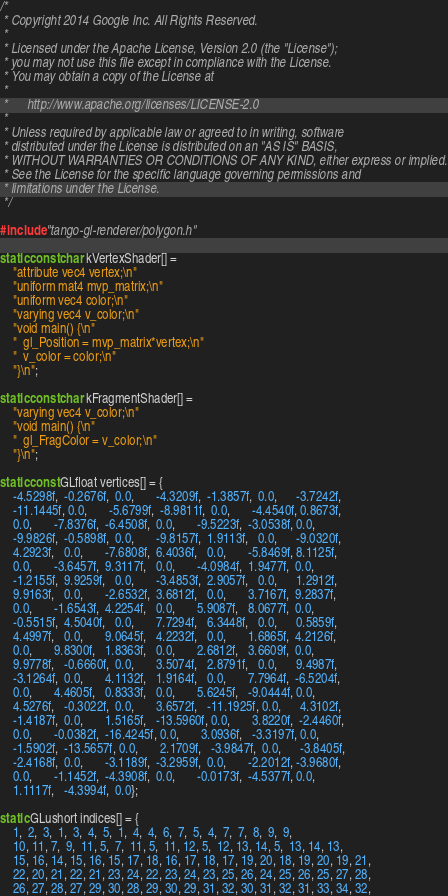Convert code to text. <code><loc_0><loc_0><loc_500><loc_500><_C++_>/*
 * Copyright 2014 Google Inc. All Rights Reserved.
 *
 * Licensed under the Apache License, Version 2.0 (the "License");
 * you may not use this file except in compliance with the License.
 * You may obtain a copy of the License at
 *
 *      http://www.apache.org/licenses/LICENSE-2.0
 *
 * Unless required by applicable law or agreed to in writing, software
 * distributed under the License is distributed on an "AS IS" BASIS,
 * WITHOUT WARRANTIES OR CONDITIONS OF ANY KIND, either express or implied.
 * See the License for the specific language governing permissions and
 * limitations under the License.
 */

#include "tango-gl-renderer/polygon.h"

static const char kVertexShader[] =
    "attribute vec4 vertex;\n"
    "uniform mat4 mvp_matrix;\n"
    "uniform vec4 color;\n"
    "varying vec4 v_color;\n"
    "void main() {\n"
    "  gl_Position = mvp_matrix*vertex;\n"
    "  v_color = color;\n"
    "}\n";

static const char kFragmentShader[] =
    "varying vec4 v_color;\n"
    "void main() {\n"
    "  gl_FragColor = v_color;\n"
    "}\n";

static const GLfloat vertices[] = {
    -4.5298f,  -0.2676f,  0.0,       -4.3209f,  -1.3857f,  0.0,      -3.7242f,
    -11.1445f, 0.0,       -5.6799f,  -8.9811f,  0.0,       -4.4540f, 0.8673f,
    0.0,       -7.8376f,  -6.4508f,  0.0,       -9.5223f,  -3.0538f, 0.0,
    -9.9826f,  -0.5898f,  0.0,       -9.8157f,  1.9113f,   0.0,      -9.0320f,
    4.2923f,   0.0,       -7.6808f,  6.4036f,   0.0,       -5.8469f, 8.1125f,
    0.0,       -3.6457f,  9.3117f,   0.0,       -4.0984f,  1.9477f,  0.0,
    -1.2155f,  9.9259f,   0.0,       -3.4853f,  2.9057f,   0.0,      1.2912f,
    9.9163f,   0.0,       -2.6532f,  3.6812f,   0.0,       3.7167f,  9.2837f,
    0.0,       -1.6543f,  4.2254f,   0.0,       5.9087f,   8.0677f,  0.0,
    -0.5515f,  4.5040f,   0.0,       7.7294f,   6.3448f,   0.0,      0.5859f,
    4.4997f,   0.0,       9.0645f,   4.2232f,   0.0,       1.6865f,  4.2126f,
    0.0,       9.8300f,   1.8363f,   0.0,       2.6812f,   3.6609f,  0.0,
    9.9778f,   -0.6660f,  0.0,       3.5074f,   2.8791f,   0.0,      9.4987f,
    -3.1264f,  0.0,       4.1132f,   1.9164f,   0.0,       7.7964f,  -6.5204f,
    0.0,       4.4605f,   0.8333f,   0.0,       5.6245f,   -9.0444f, 0.0,
    4.5276f,   -0.3022f,  0.0,       3.6572f,   -11.1925f, 0.0,      4.3102f,
    -1.4187f,  0.0,       1.5165f,   -13.5960f, 0.0,       3.8220f,  -2.4460f,
    0.0,       -0.0382f,  -16.4245f, 0.0,       3.0936f,   -3.3197f, 0.0,
    -1.5902f,  -13.5657f, 0.0,       2.1709f,   -3.9847f,  0.0,      -3.8405f,
    -2.4168f,  0.0,       -3.1189f,  -3.2959f,  0.0,       -2.2012f, -3.9680f,
    0.0,       -1.1452f,  -4.3908f,  0.0,       -0.0173f,  -4.5377f, 0.0,
    1.1117f,   -4.3994f,  0.0};

static GLushort indices[] = {
    1,  2,  3,  1,  3,  4,  5,  1,  4,  4,  6,  7,  5,  4,  7,  7,  8,  9,  9,
    10, 11, 7,  9,  11, 5,  7,  11, 5,  11, 12, 5,  12, 13, 14, 5,  13, 14, 13,
    15, 16, 14, 15, 16, 15, 17, 18, 16, 17, 18, 17, 19, 20, 18, 19, 20, 19, 21,
    22, 20, 21, 22, 21, 23, 24, 22, 23, 24, 23, 25, 26, 24, 25, 26, 25, 27, 28,
    26, 27, 28, 27, 29, 30, 28, 29, 30, 29, 31, 32, 30, 31, 32, 31, 33, 34, 32,</code> 